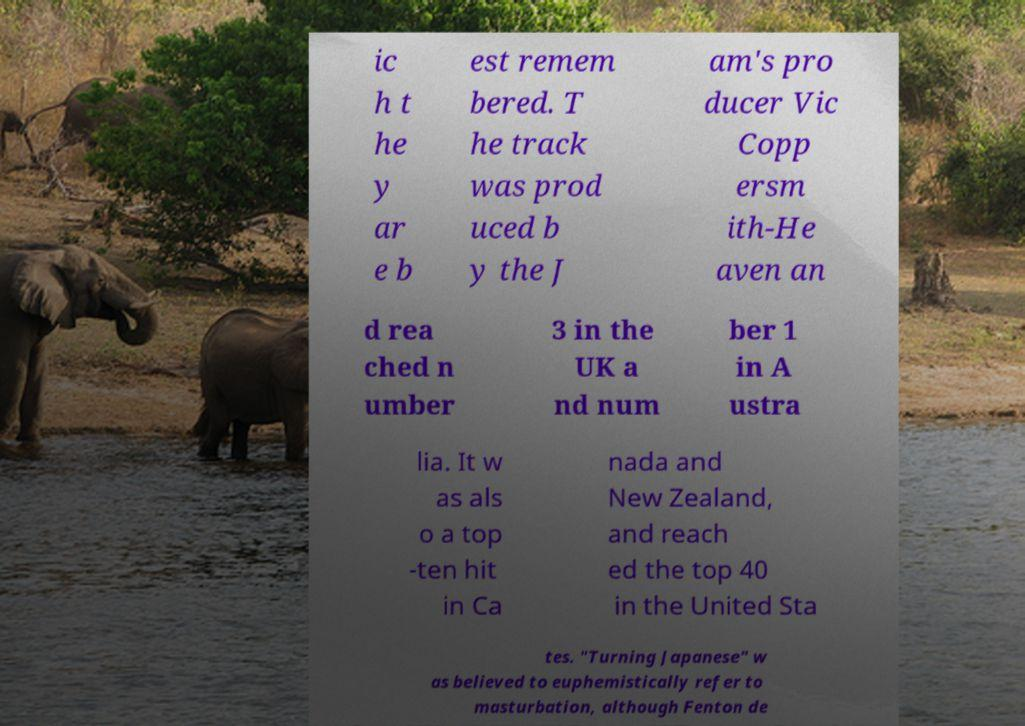Please read and relay the text visible in this image. What does it say? ic h t he y ar e b est remem bered. T he track was prod uced b y the J am's pro ducer Vic Copp ersm ith-He aven an d rea ched n umber 3 in the UK a nd num ber 1 in A ustra lia. It w as als o a top -ten hit in Ca nada and New Zealand, and reach ed the top 40 in the United Sta tes. "Turning Japanese" w as believed to euphemistically refer to masturbation, although Fenton de 